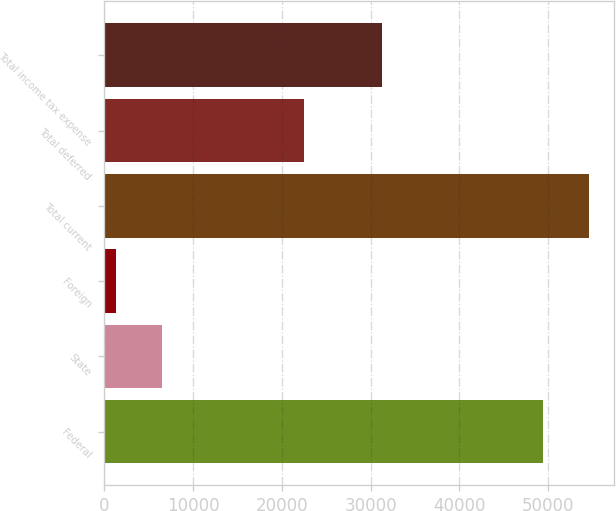Convert chart. <chart><loc_0><loc_0><loc_500><loc_500><bar_chart><fcel>Federal<fcel>State<fcel>Foreign<fcel>Total current<fcel>Total deferred<fcel>Total income tax expense<nl><fcel>49384<fcel>6517.9<fcel>1262<fcel>54639.9<fcel>22490<fcel>31331<nl></chart> 